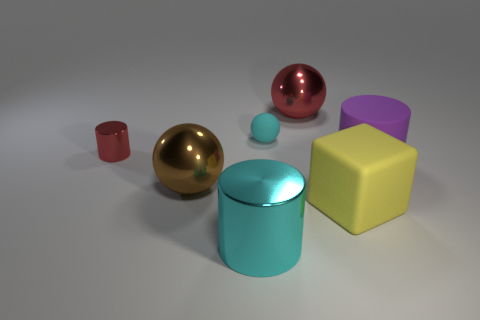Subtract all big red balls. How many balls are left? 2 Add 3 cyan shiny balls. How many objects exist? 10 Add 1 large cyan spheres. How many large cyan spheres exist? 1 Subtract all red spheres. How many spheres are left? 2 Subtract 0 yellow cylinders. How many objects are left? 7 Subtract all balls. How many objects are left? 4 Subtract 2 balls. How many balls are left? 1 Subtract all green cubes. Subtract all gray cylinders. How many cubes are left? 1 Subtract all green metal objects. Subtract all tiny cyan balls. How many objects are left? 6 Add 1 big brown shiny things. How many big brown shiny things are left? 2 